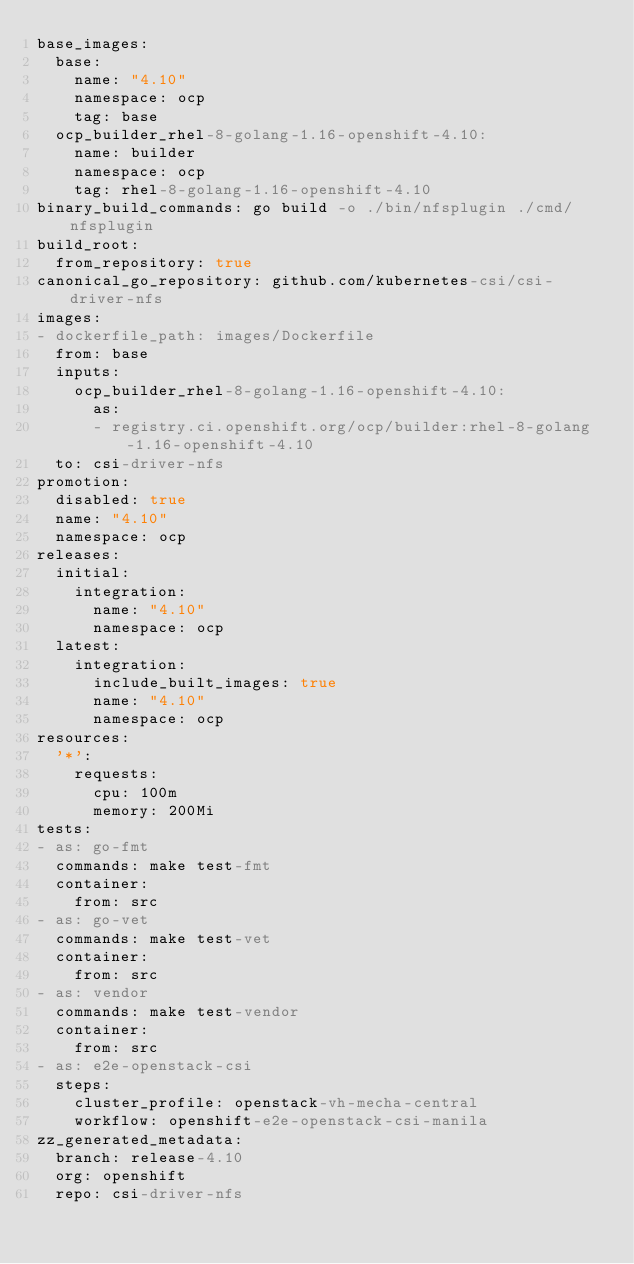<code> <loc_0><loc_0><loc_500><loc_500><_YAML_>base_images:
  base:
    name: "4.10"
    namespace: ocp
    tag: base
  ocp_builder_rhel-8-golang-1.16-openshift-4.10:
    name: builder
    namespace: ocp
    tag: rhel-8-golang-1.16-openshift-4.10
binary_build_commands: go build -o ./bin/nfsplugin ./cmd/nfsplugin
build_root:
  from_repository: true
canonical_go_repository: github.com/kubernetes-csi/csi-driver-nfs
images:
- dockerfile_path: images/Dockerfile
  from: base
  inputs:
    ocp_builder_rhel-8-golang-1.16-openshift-4.10:
      as:
      - registry.ci.openshift.org/ocp/builder:rhel-8-golang-1.16-openshift-4.10
  to: csi-driver-nfs
promotion:
  disabled: true
  name: "4.10"
  namespace: ocp
releases:
  initial:
    integration:
      name: "4.10"
      namespace: ocp
  latest:
    integration:
      include_built_images: true
      name: "4.10"
      namespace: ocp
resources:
  '*':
    requests:
      cpu: 100m
      memory: 200Mi
tests:
- as: go-fmt
  commands: make test-fmt
  container:
    from: src
- as: go-vet
  commands: make test-vet
  container:
    from: src
- as: vendor
  commands: make test-vendor
  container:
    from: src
- as: e2e-openstack-csi
  steps:
    cluster_profile: openstack-vh-mecha-central
    workflow: openshift-e2e-openstack-csi-manila
zz_generated_metadata:
  branch: release-4.10
  org: openshift
  repo: csi-driver-nfs
</code> 